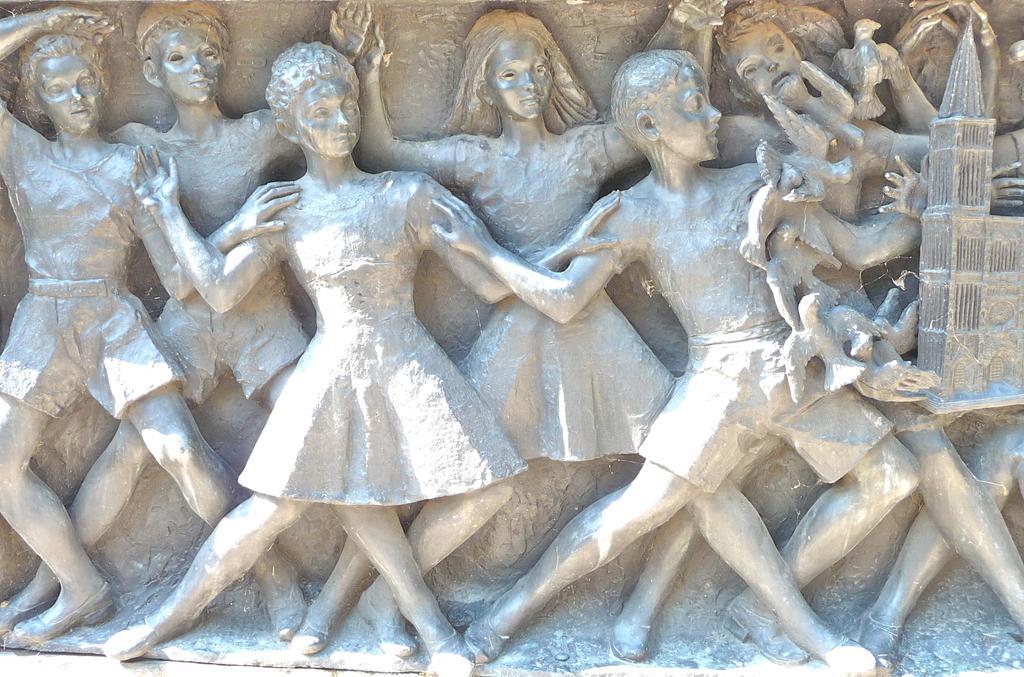In one or two sentences, can you explain what this image depicts? In this picture we can see few sculptures. 